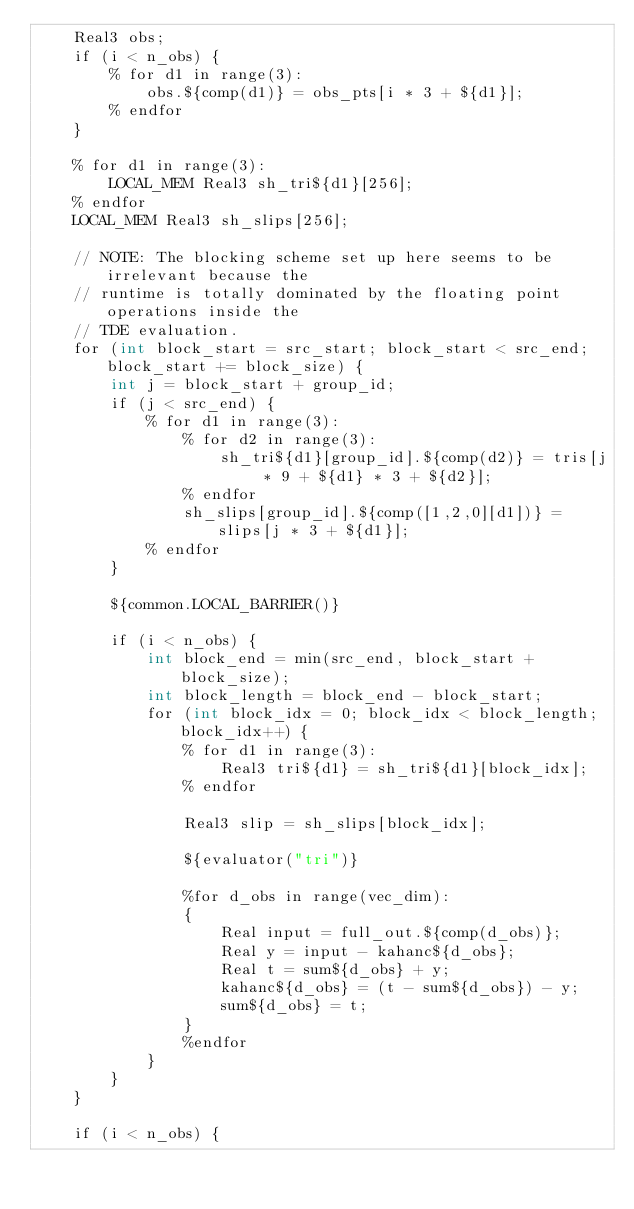<code> <loc_0><loc_0><loc_500><loc_500><_Cuda_>    Real3 obs;
    if (i < n_obs) {
        % for d1 in range(3):
            obs.${comp(d1)} = obs_pts[i * 3 + ${d1}];
        % endfor
    }

    % for d1 in range(3):
        LOCAL_MEM Real3 sh_tri${d1}[256];
    % endfor
    LOCAL_MEM Real3 sh_slips[256];

    // NOTE: The blocking scheme set up here seems to be irrelevant because the
    // runtime is totally dominated by the floating point operations inside the
    // TDE evaluation.
    for (int block_start = src_start; block_start < src_end; block_start += block_size) {
        int j = block_start + group_id;
        if (j < src_end) {
            % for d1 in range(3):
                % for d2 in range(3):
                    sh_tri${d1}[group_id].${comp(d2)} = tris[j * 9 + ${d1} * 3 + ${d2}];
                % endfor
                sh_slips[group_id].${comp([1,2,0][d1])} = slips[j * 3 + ${d1}];
            % endfor
        }

        ${common.LOCAL_BARRIER()}

        if (i < n_obs) {
            int block_end = min(src_end, block_start + block_size);
            int block_length = block_end - block_start;
            for (int block_idx = 0; block_idx < block_length; block_idx++) {
                % for d1 in range(3):
                    Real3 tri${d1} = sh_tri${d1}[block_idx];
                % endfor

                Real3 slip = sh_slips[block_idx];

                ${evaluator("tri")}

                %for d_obs in range(vec_dim):
                {
                    Real input = full_out.${comp(d_obs)};
                    Real y = input - kahanc${d_obs};
                    Real t = sum${d_obs} + y;
                    kahanc${d_obs} = (t - sum${d_obs}) - y;
                    sum${d_obs} = t;
                }
                %endfor
            }
        }
    }

    if (i < n_obs) {</code> 